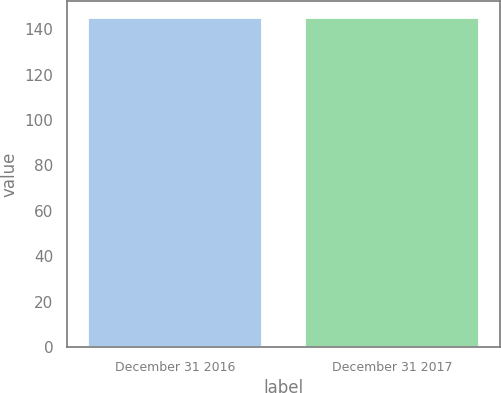<chart> <loc_0><loc_0><loc_500><loc_500><bar_chart><fcel>December 31 2016<fcel>December 31 2017<nl><fcel>144.9<fcel>145<nl></chart> 